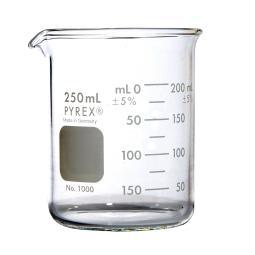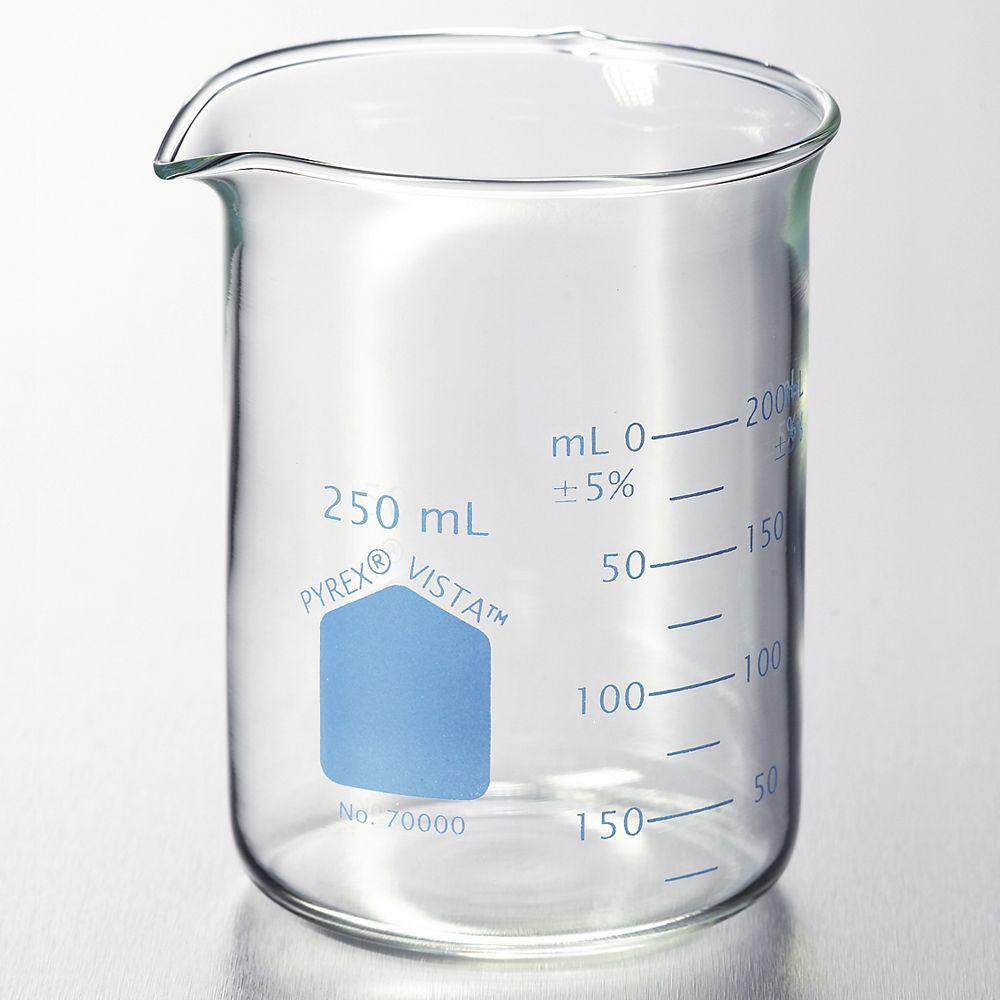The first image is the image on the left, the second image is the image on the right. For the images displayed, is the sentence "there are clear beakers with a blue background" factually correct? Answer yes or no. No. The first image is the image on the left, the second image is the image on the right. Assess this claim about the two images: "The image on the left has three beakers and the smallest one has a pink fluid.". Correct or not? Answer yes or no. No. 